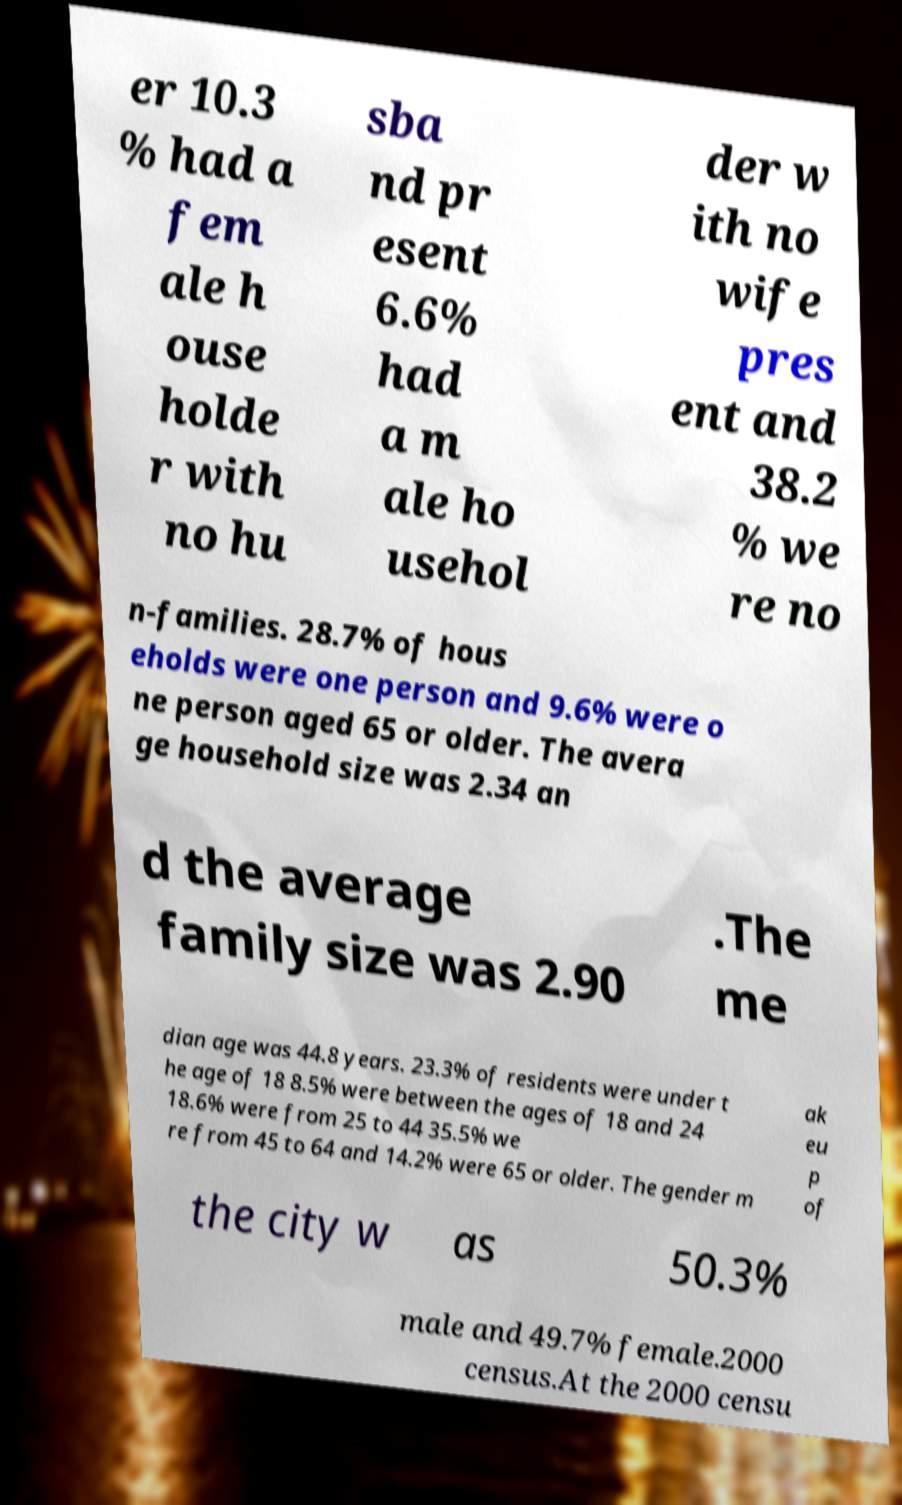What messages or text are displayed in this image? I need them in a readable, typed format. er 10.3 % had a fem ale h ouse holde r with no hu sba nd pr esent 6.6% had a m ale ho usehol der w ith no wife pres ent and 38.2 % we re no n-families. 28.7% of hous eholds were one person and 9.6% were o ne person aged 65 or older. The avera ge household size was 2.34 an d the average family size was 2.90 .The me dian age was 44.8 years. 23.3% of residents were under t he age of 18 8.5% were between the ages of 18 and 24 18.6% were from 25 to 44 35.5% we re from 45 to 64 and 14.2% were 65 or older. The gender m ak eu p of the city w as 50.3% male and 49.7% female.2000 census.At the 2000 censu 